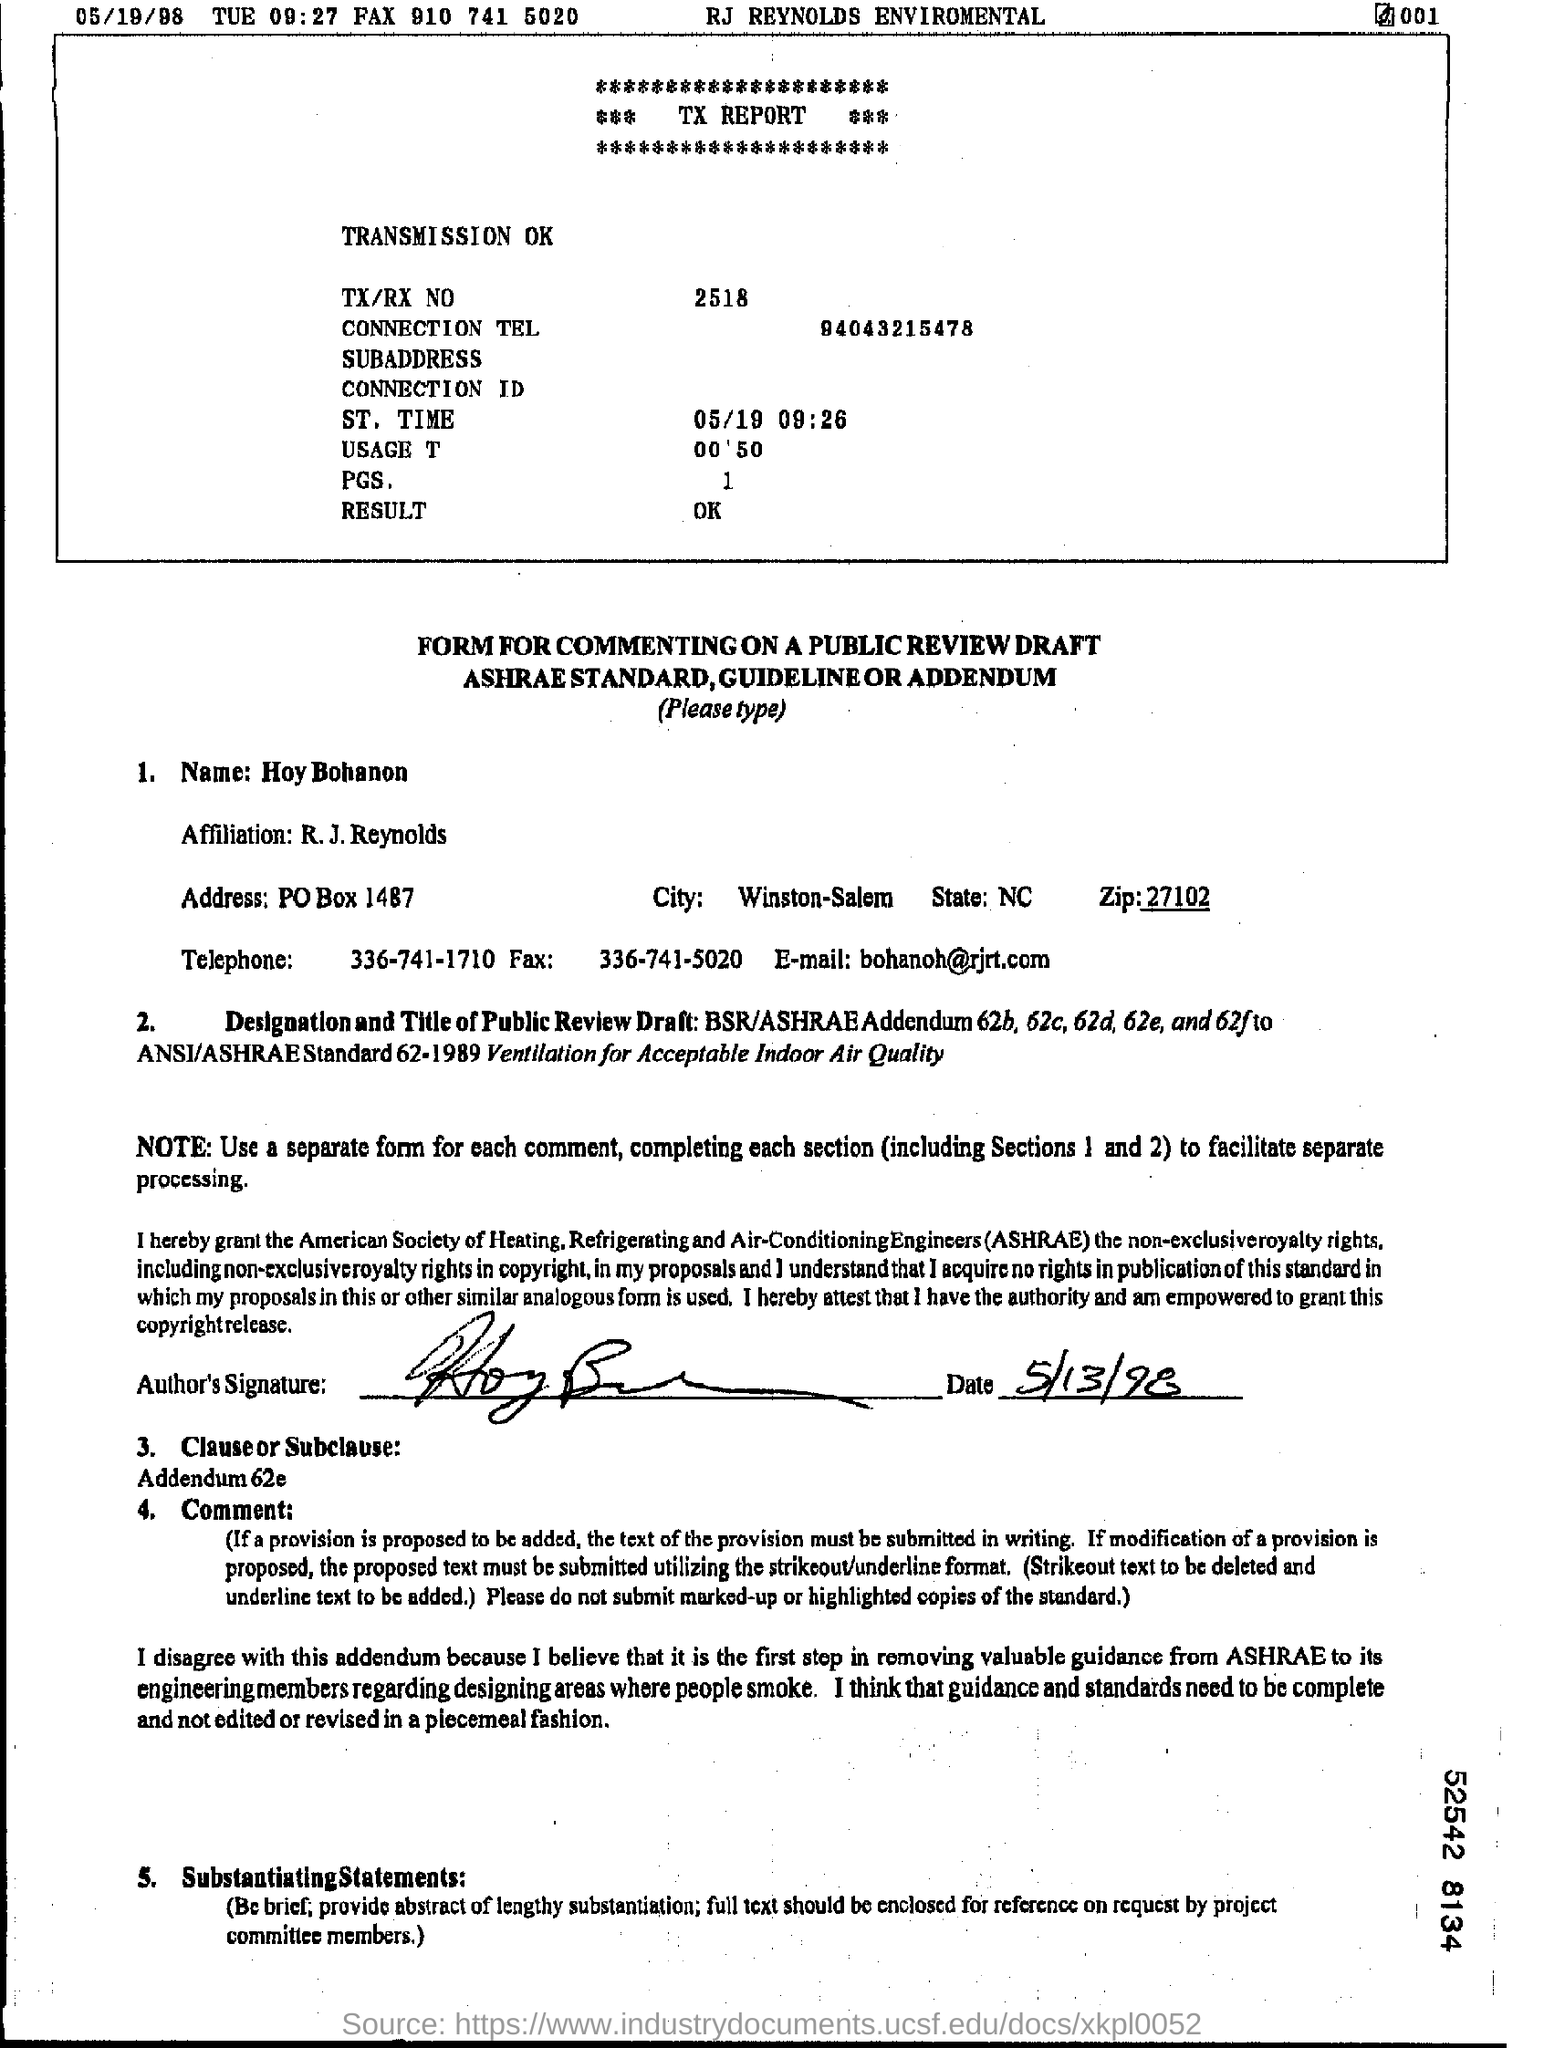Outline some significant characteristics in this image. The telephone number of Hoy Bohanon is 336-741-1710. The TX/RX number is 2518. The email address of Hoy Bohanon is [bohanoh@rjrt.com](mailto:bohanoh@rjrt.com). 